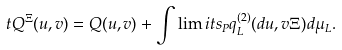<formula> <loc_0><loc_0><loc_500><loc_500>\ t Q ^ { \Xi } ( u , v ) = Q ( u , v ) + \int \lim i t s _ { P } q ^ { ( 2 ) } _ { L } ( d u , v \Xi ) d \mu _ { L } .</formula> 